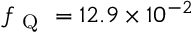<formula> <loc_0><loc_0><loc_500><loc_500>f _ { Q } = 1 2 . 9 \times 1 0 ^ { - 2 }</formula> 